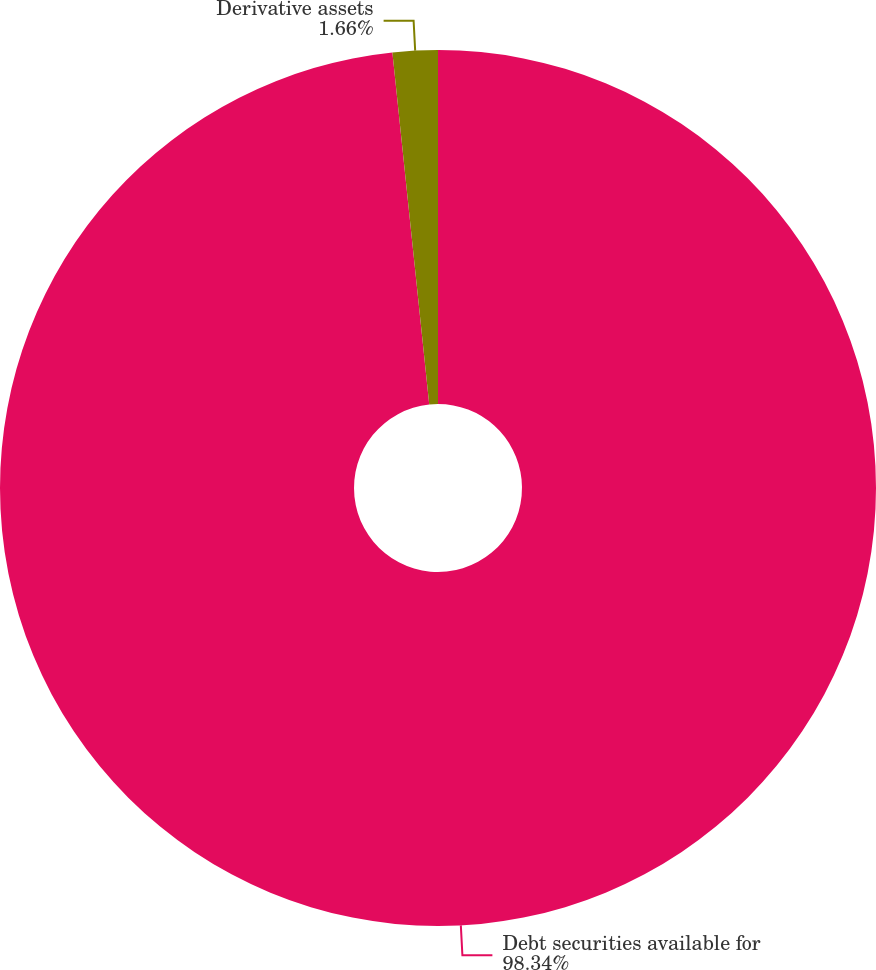Convert chart. <chart><loc_0><loc_0><loc_500><loc_500><pie_chart><fcel>Debt securities available for<fcel>Derivative assets<nl><fcel>98.34%<fcel>1.66%<nl></chart> 